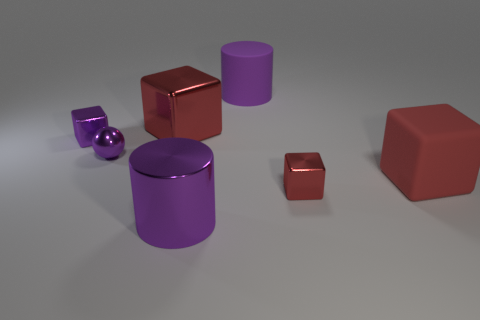How many shiny things are both in front of the small purple cube and on the right side of the sphere?
Give a very brief answer. 2. Do the metal sphere and the large matte cylinder have the same color?
Provide a succinct answer. Yes. What is the material of the other big thing that is the same shape as the large purple rubber object?
Give a very brief answer. Metal. Is there anything else that has the same material as the small purple ball?
Keep it short and to the point. Yes. Is the number of large matte objects right of the purple rubber cylinder the same as the number of big purple objects behind the big shiny cylinder?
Offer a very short reply. Yes. Is the tiny purple ball made of the same material as the small red object?
Give a very brief answer. Yes. What number of purple things are tiny spheres or metal cylinders?
Offer a terse response. 2. How many cyan metal objects are the same shape as the tiny red object?
Your answer should be compact. 0. What is the material of the purple block?
Your answer should be compact. Metal. Are there the same number of big matte cylinders behind the matte cube and balls?
Offer a terse response. Yes. 